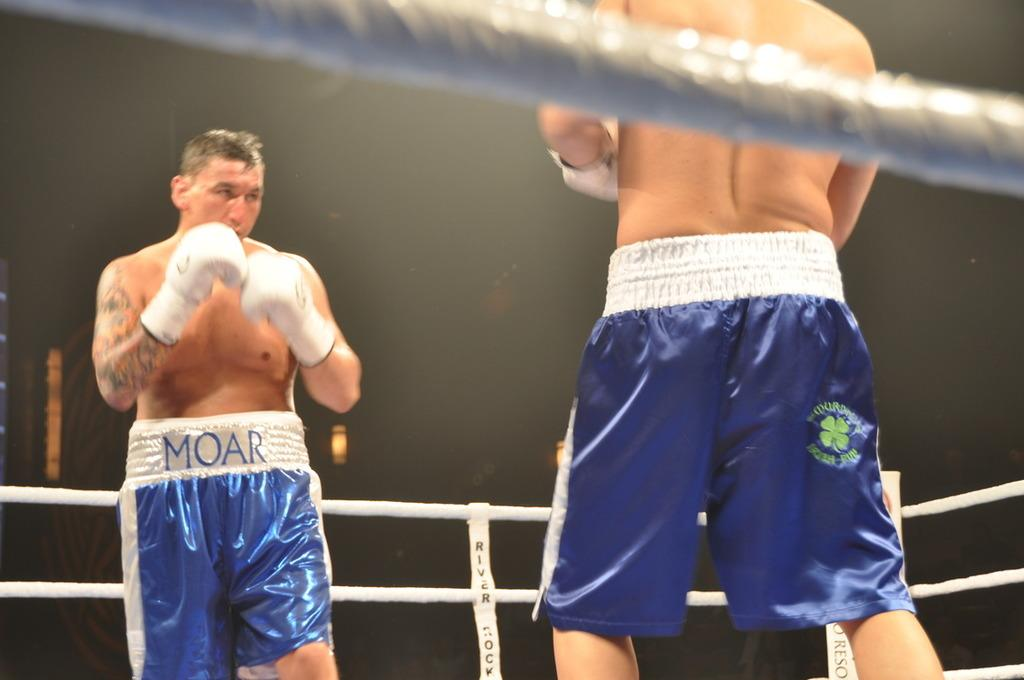<image>
Render a clear and concise summary of the photo. two guys and one with moar on his shorts 